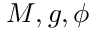Convert formula to latex. <formula><loc_0><loc_0><loc_500><loc_500>M , g , \phi</formula> 